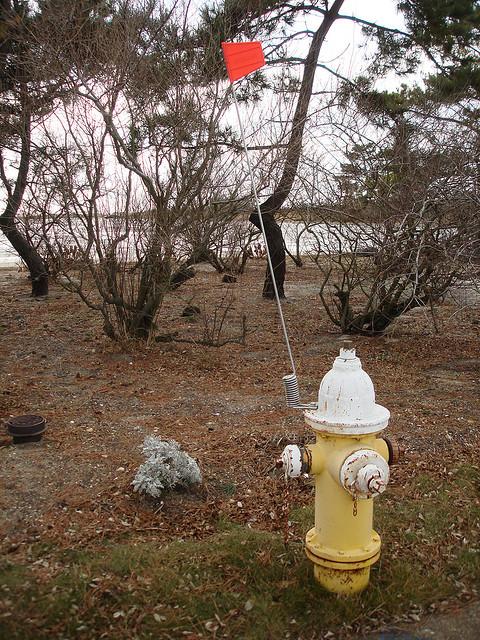Is this fire hydrant brand new?
Write a very short answer. No. What is on the fire hydrant?
Concise answer only. Flag. Is there water present?
Concise answer only. Yes. 